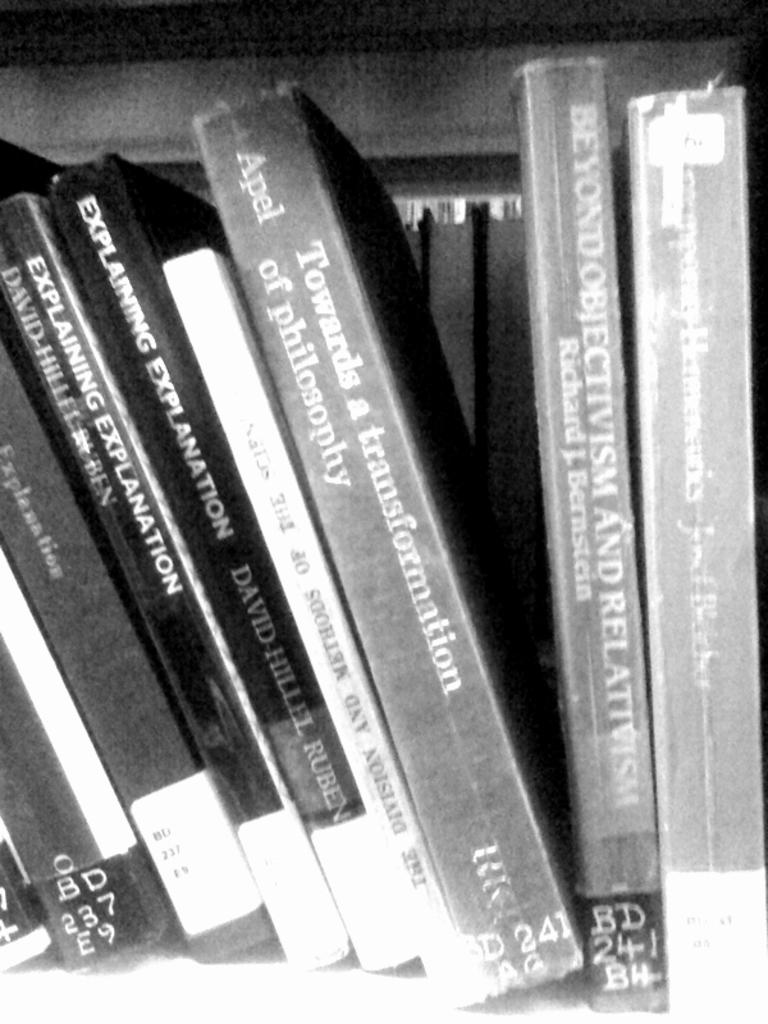<image>
Relay a brief, clear account of the picture shown. A book titled Explaining Explanation is shelved among other works on philosophy 